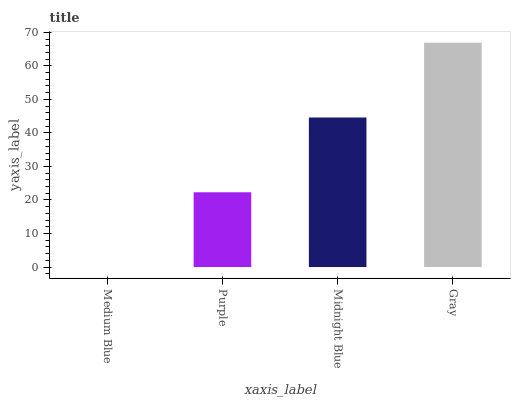Is Medium Blue the minimum?
Answer yes or no. Yes. Is Gray the maximum?
Answer yes or no. Yes. Is Purple the minimum?
Answer yes or no. No. Is Purple the maximum?
Answer yes or no. No. Is Purple greater than Medium Blue?
Answer yes or no. Yes. Is Medium Blue less than Purple?
Answer yes or no. Yes. Is Medium Blue greater than Purple?
Answer yes or no. No. Is Purple less than Medium Blue?
Answer yes or no. No. Is Midnight Blue the high median?
Answer yes or no. Yes. Is Purple the low median?
Answer yes or no. Yes. Is Purple the high median?
Answer yes or no. No. Is Midnight Blue the low median?
Answer yes or no. No. 